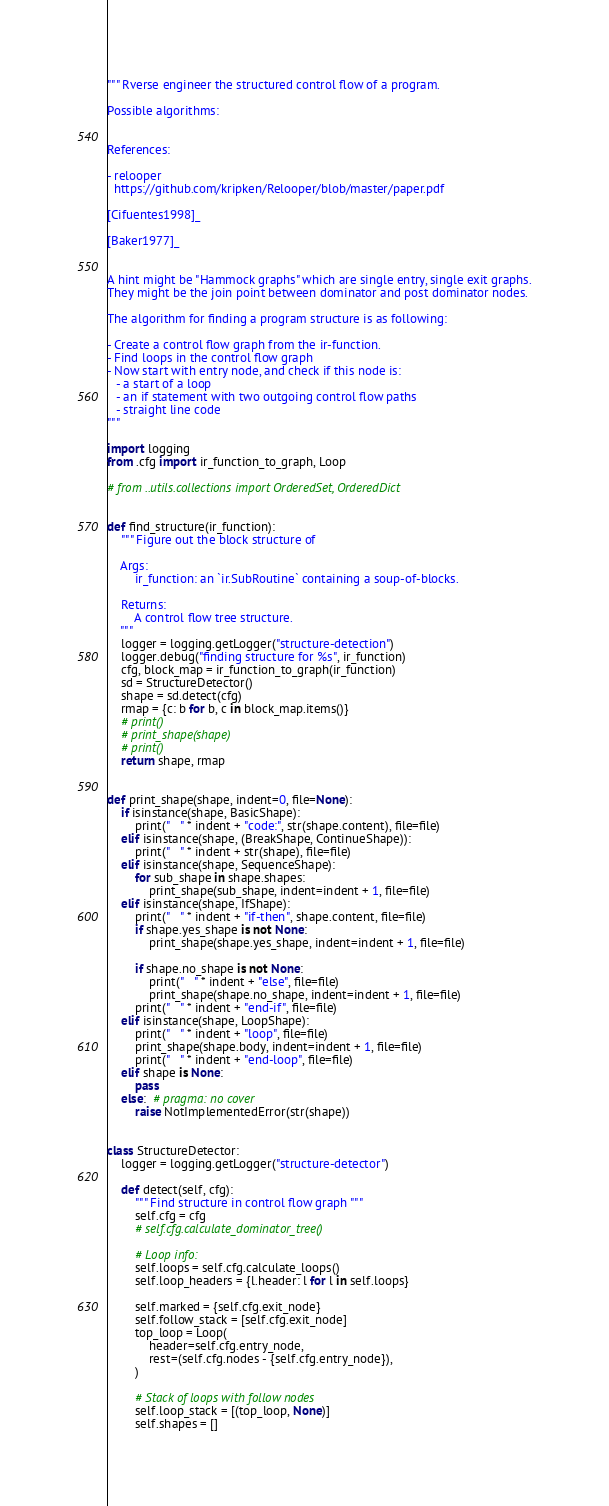<code> <loc_0><loc_0><loc_500><loc_500><_Python_>""" Rverse engineer the structured control flow of a program.

Possible algorithms:


References:

- relooper
  https://github.com/kripken/Relooper/blob/master/paper.pdf

[Cifuentes1998]_

[Baker1977]_


A hint might be "Hammock graphs" which are single entry, single exit graphs.
They might be the join point between dominator and post dominator nodes.

The algorithm for finding a program structure is as following:

- Create a control flow graph from the ir-function.
- Find loops in the control flow graph
- Now start with entry node, and check if this node is:
   - a start of a loop
   - an if statement with two outgoing control flow paths
   - straight line code
"""

import logging
from .cfg import ir_function_to_graph, Loop

# from ..utils.collections import OrderedSet, OrderedDict


def find_structure(ir_function):
    """ Figure out the block structure of

    Args:
        ir_function: an `ir.SubRoutine` containing a soup-of-blocks.

    Returns:
        A control flow tree structure.
    """
    logger = logging.getLogger("structure-detection")
    logger.debug("finding structure for %s", ir_function)
    cfg, block_map = ir_function_to_graph(ir_function)
    sd = StructureDetector()
    shape = sd.detect(cfg)
    rmap = {c: b for b, c in block_map.items()}
    # print()
    # print_shape(shape)
    # print()
    return shape, rmap


def print_shape(shape, indent=0, file=None):
    if isinstance(shape, BasicShape):
        print("   " * indent + "code:", str(shape.content), file=file)
    elif isinstance(shape, (BreakShape, ContinueShape)):
        print("   " * indent + str(shape), file=file)
    elif isinstance(shape, SequenceShape):
        for sub_shape in shape.shapes:
            print_shape(sub_shape, indent=indent + 1, file=file)
    elif isinstance(shape, IfShape):
        print("   " * indent + "if-then", shape.content, file=file)
        if shape.yes_shape is not None:
            print_shape(shape.yes_shape, indent=indent + 1, file=file)

        if shape.no_shape is not None:
            print("   " * indent + "else", file=file)
            print_shape(shape.no_shape, indent=indent + 1, file=file)
        print("   " * indent + "end-if", file=file)
    elif isinstance(shape, LoopShape):
        print("   " * indent + "loop", file=file)
        print_shape(shape.body, indent=indent + 1, file=file)
        print("   " * indent + "end-loop", file=file)
    elif shape is None:
        pass
    else:  # pragma: no cover
        raise NotImplementedError(str(shape))


class StructureDetector:
    logger = logging.getLogger("structure-detector")

    def detect(self, cfg):
        """ Find structure in control flow graph """
        self.cfg = cfg
        # self.cfg.calculate_dominator_tree()

        # Loop info:
        self.loops = self.cfg.calculate_loops()
        self.loop_headers = {l.header: l for l in self.loops}

        self.marked = {self.cfg.exit_node}
        self.follow_stack = [self.cfg.exit_node]
        top_loop = Loop(
            header=self.cfg.entry_node,
            rest=(self.cfg.nodes - {self.cfg.entry_node}),
        )

        # Stack of loops with follow nodes
        self.loop_stack = [(top_loop, None)]
        self.shapes = []</code> 